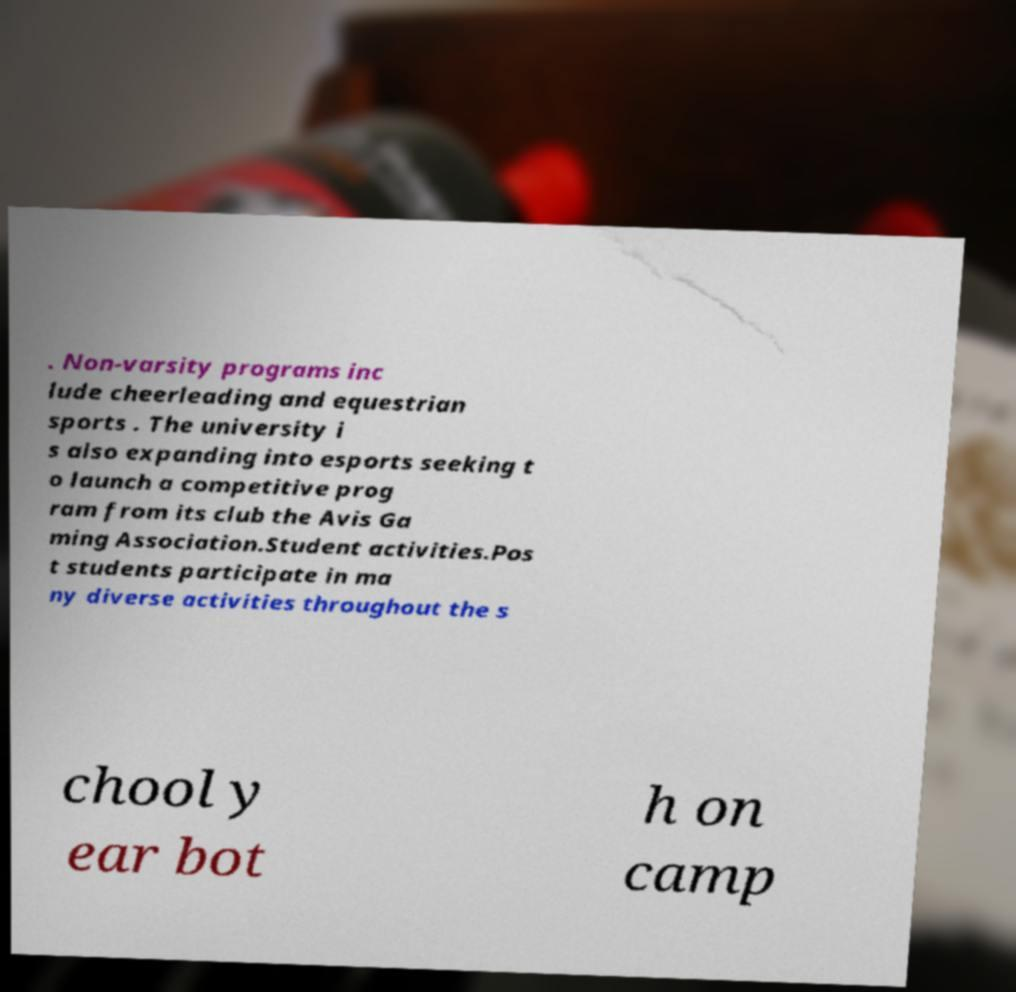Can you read and provide the text displayed in the image?This photo seems to have some interesting text. Can you extract and type it out for me? . Non-varsity programs inc lude cheerleading and equestrian sports . The university i s also expanding into esports seeking t o launch a competitive prog ram from its club the Avis Ga ming Association.Student activities.Pos t students participate in ma ny diverse activities throughout the s chool y ear bot h on camp 